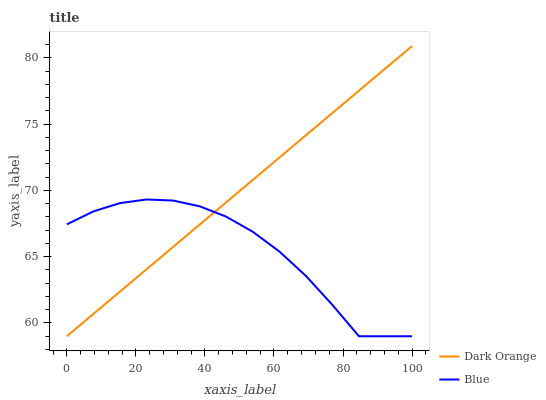Does Blue have the minimum area under the curve?
Answer yes or no. Yes. Does Dark Orange have the maximum area under the curve?
Answer yes or no. Yes. Does Dark Orange have the minimum area under the curve?
Answer yes or no. No. Is Dark Orange the smoothest?
Answer yes or no. Yes. Is Blue the roughest?
Answer yes or no. Yes. Is Dark Orange the roughest?
Answer yes or no. No. Does Blue have the lowest value?
Answer yes or no. Yes. Does Dark Orange have the highest value?
Answer yes or no. Yes. Does Dark Orange intersect Blue?
Answer yes or no. Yes. Is Dark Orange less than Blue?
Answer yes or no. No. Is Dark Orange greater than Blue?
Answer yes or no. No. 